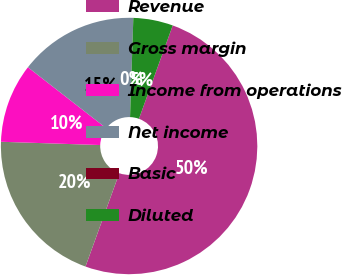<chart> <loc_0><loc_0><loc_500><loc_500><pie_chart><fcel>Revenue<fcel>Gross margin<fcel>Income from operations<fcel>Net income<fcel>Basic<fcel>Diluted<nl><fcel>50.0%<fcel>20.0%<fcel>10.0%<fcel>15.0%<fcel>0.0%<fcel>5.0%<nl></chart> 